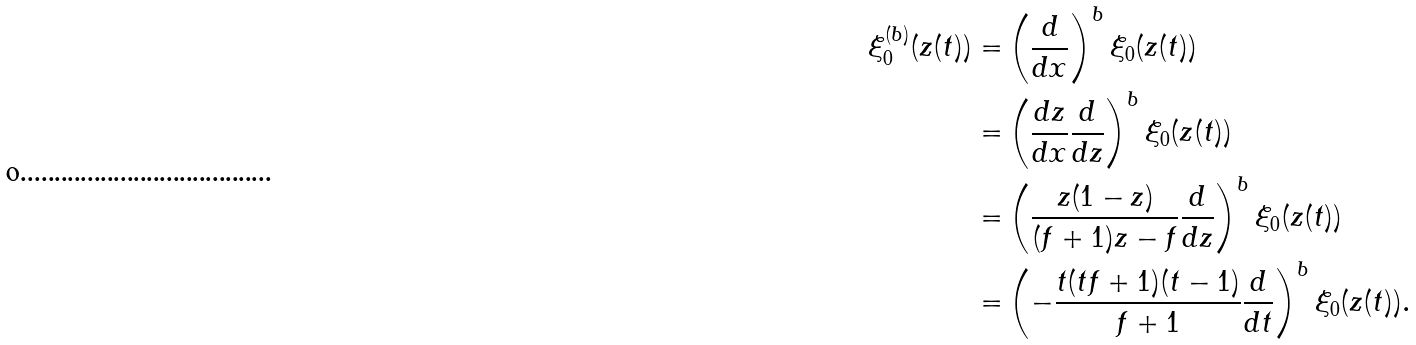Convert formula to latex. <formula><loc_0><loc_0><loc_500><loc_500>\xi _ { 0 } ^ { ( b ) } ( z ( t ) ) = & \left ( \frac { d } { d x } \right ) ^ { b } \xi _ { 0 } ( z ( t ) ) \\ = & \left ( \frac { d z } { d x } \frac { d } { d z } \right ) ^ { b } \xi _ { 0 } ( z ( t ) ) \\ = & \left ( \frac { z ( 1 - z ) } { ( f + 1 ) z - f } \frac { d } { d z } \right ) ^ { b } \xi _ { 0 } ( z ( t ) ) \\ = & \left ( - \frac { t ( t f + 1 ) ( t - 1 ) } { f + 1 } \frac { d } { d t } \right ) ^ { b } \xi _ { 0 } ( z ( t ) ) .</formula> 